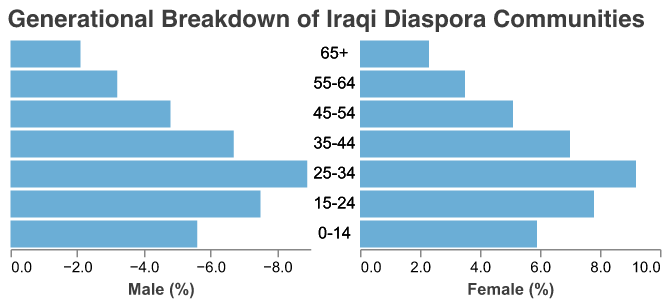What is the title of the figure? The title of the figure is located at the top of the chart and provides the main subject of the visualization.
Answer: Generational Breakdown of Iraqi Diaspora Communities Which age group has the highest percentage for males? To find the highest percentage among males, look at the bars representing male percentages and identify the one that extends the farthest to the left.
Answer: 25-34 Which age group has a higher representation of females than males? Check the percentage values for each age group and compare the female bars to the male bars to find those where the female bar is longer.
Answer: All age groups What is the difference in percentage between males and females in the 25-34 age group? For the 25-34 age group, the male percentage is 8.9%, and the female percentage is 9.2%. Subtract the male percentage from the female percentage.
Answer: 0.3% What is the sum of the percentages for males and females in the 55-64 age group? Add the male percentage (3.2%) to the female percentage (3.5%) for the 55-64 age group.
Answer: 6.7% Which gender has a higher representation in the 15-24 age group and by how much? Compare the male (7.5%) and female (7.8%) percentages in the 15-24 group; the female percentage is higher. Subtract the male value from the female value.
Answer: Female, by 0.3% What age group has the smallest representation for both genders? Identify the age group with the smallest combined male and female percentages by comparing the total bars for each age group.
Answer: 65+ How does language retention compare to traditional music participation among the Iraqi diaspora? Compare the given percentage values for traditional music participation (Male: 62%, Female: 58%) and language retention (Male: 45%, Female: 48%) to determine the trend.
Answer: Traditional music participation is higher than language retention 